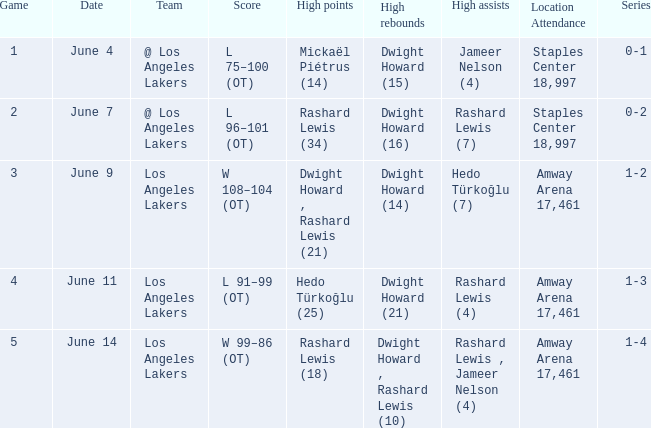What is Team, when High Assists is "Rashard Lewis (4)"? Los Angeles Lakers. 